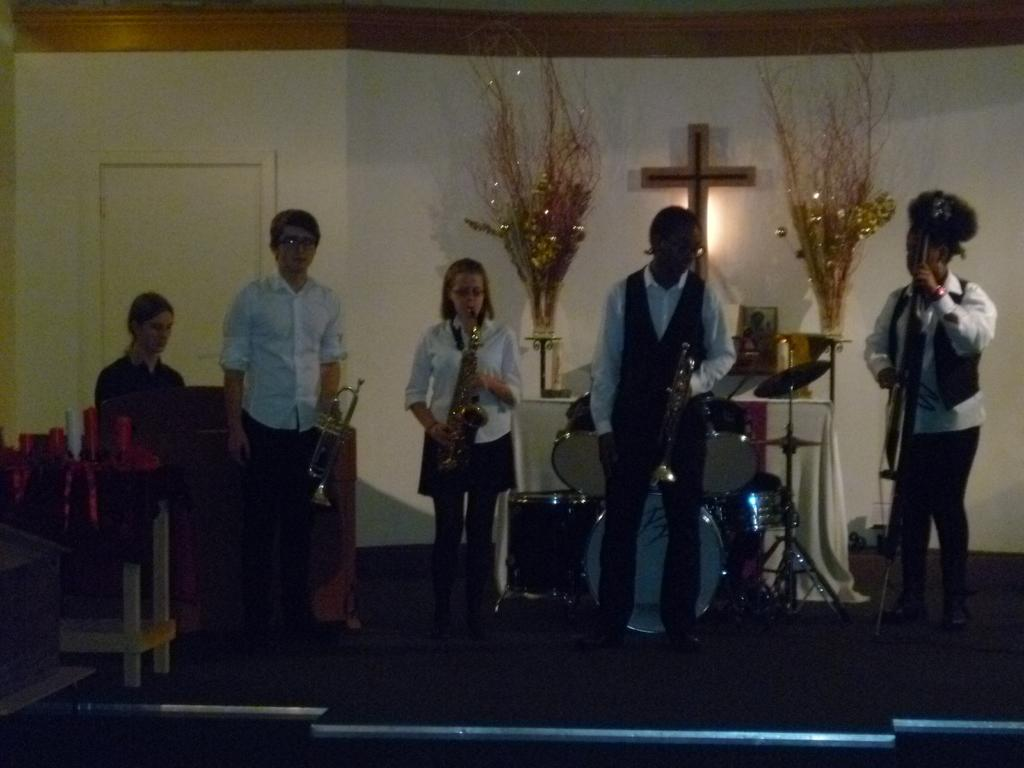How many people are in the image? There is a group of people in the image, but the exact number cannot be determined from the provided facts. What are the people in the image doing? The presence of musical instruments suggests that the people might be playing music or participating in a musical event. What can be seen in the background of the image? There is a wall in the background of the image. What type of paste is being used by the people in the image? There is no mention of paste in the image, so it cannot be determined what type of paste might be present or being used. 